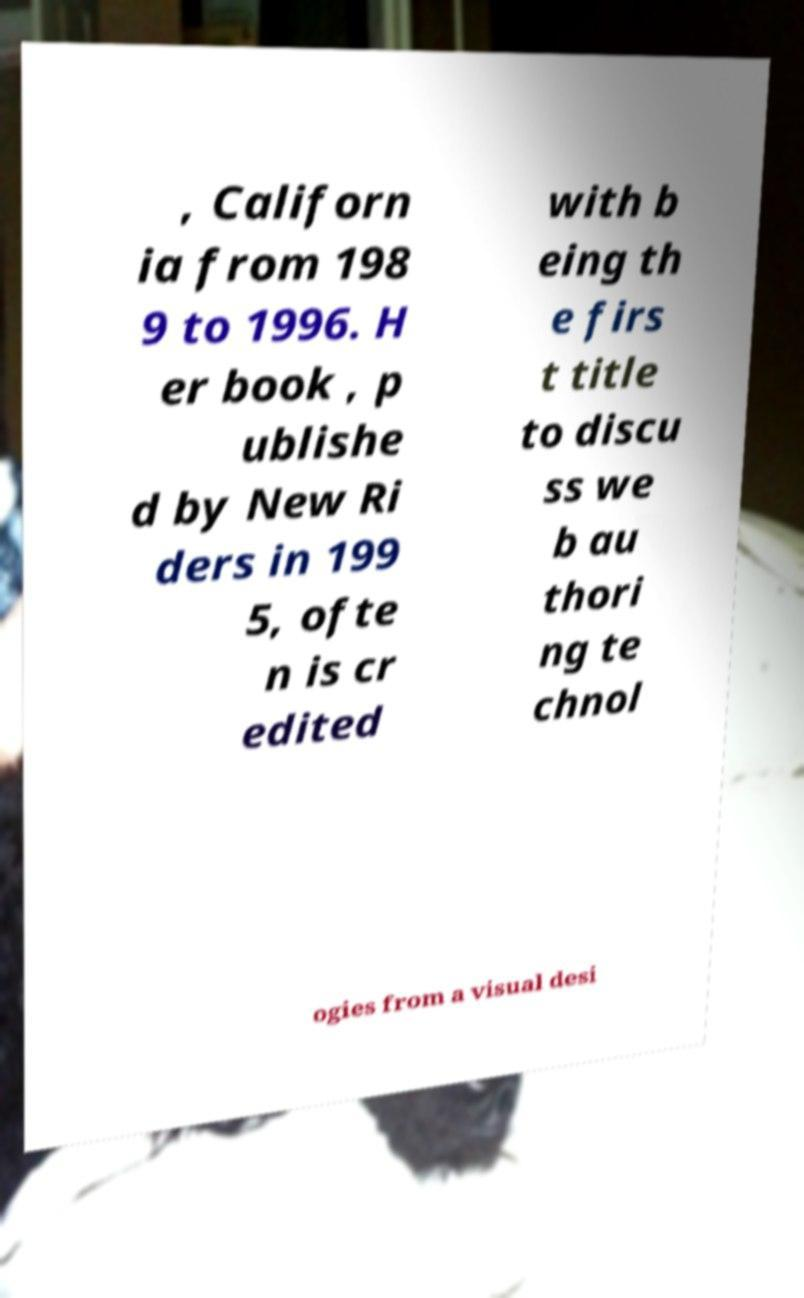Could you assist in decoding the text presented in this image and type it out clearly? , Californ ia from 198 9 to 1996. H er book , p ublishe d by New Ri ders in 199 5, ofte n is cr edited with b eing th e firs t title to discu ss we b au thori ng te chnol ogies from a visual desi 